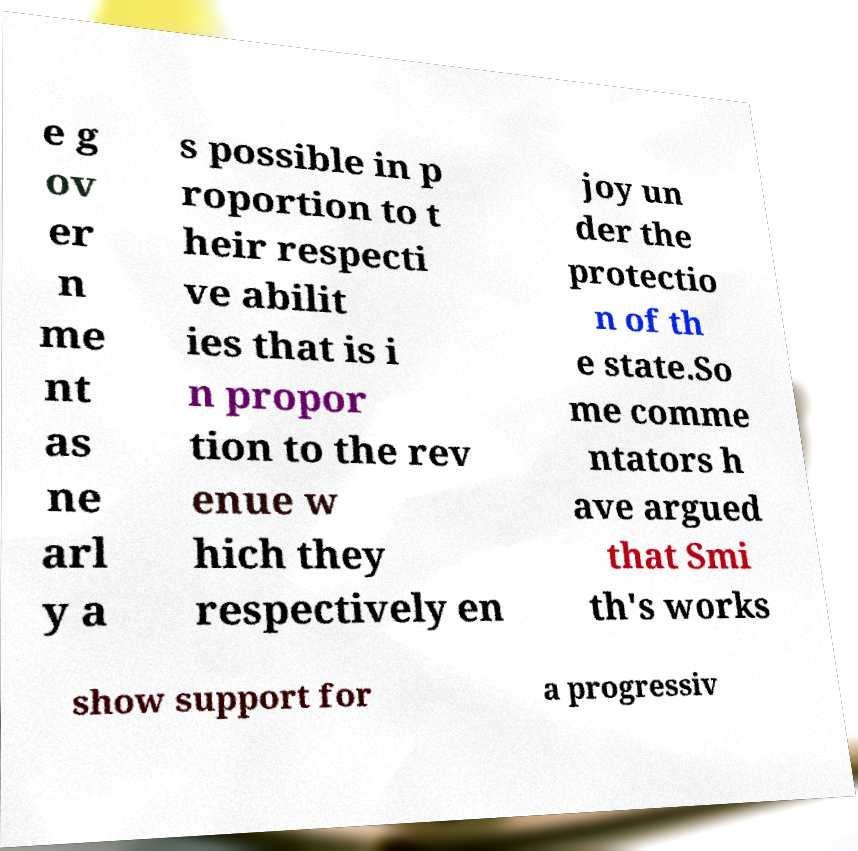Can you accurately transcribe the text from the provided image for me? e g ov er n me nt as ne arl y a s possible in p roportion to t heir respecti ve abilit ies that is i n propor tion to the rev enue w hich they respectively en joy un der the protectio n of th e state.So me comme ntators h ave argued that Smi th's works show support for a progressiv 